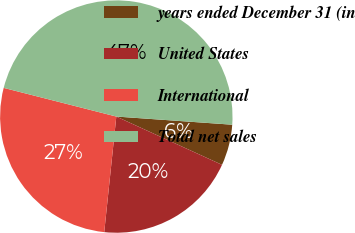Convert chart to OTSL. <chart><loc_0><loc_0><loc_500><loc_500><pie_chart><fcel>years ended December 31 (in<fcel>United States<fcel>International<fcel>Total net sales<nl><fcel>5.7%<fcel>19.84%<fcel>27.31%<fcel>47.15%<nl></chart> 